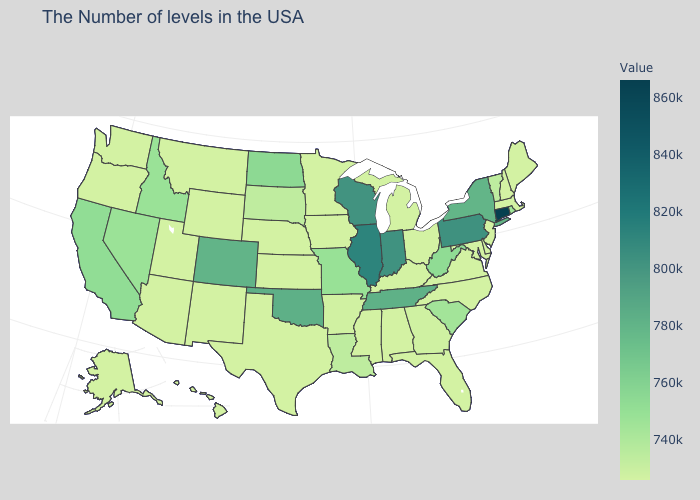Does Connecticut have the highest value in the Northeast?
Short answer required. Yes. Which states have the highest value in the USA?
Quick response, please. Connecticut. Does Massachusetts have the lowest value in the USA?
Quick response, please. Yes. Among the states that border South Carolina , does Georgia have the highest value?
Give a very brief answer. Yes. Which states have the lowest value in the MidWest?
Concise answer only. Ohio, Michigan, Minnesota, Iowa, Kansas, Nebraska. 